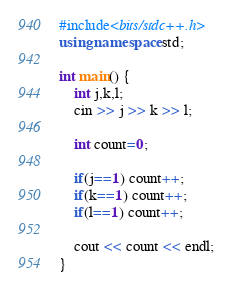<code> <loc_0><loc_0><loc_500><loc_500><_C++_>#include<bits/stdc++.h>
using namespace std;

int main() {
 	int j,k,l;
  	cin >> j >> k >> l;
  
  	int count=0;
  	
  	if(j==1) count++;
 	if(k==1) count++;
  	if(l==1) count++;
  
  	cout << count << endl;
}</code> 